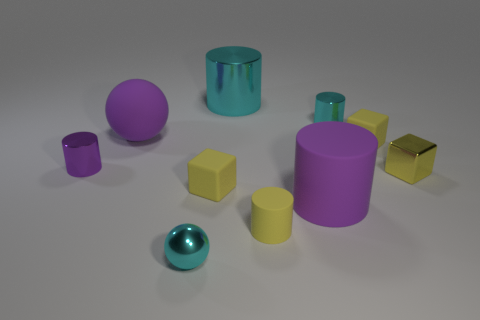Is there any other thing that is the same size as the matte sphere?
Keep it short and to the point. Yes. There is a small matte cube to the right of the small yellow rubber cylinder; is it the same color as the small matte cylinder?
Ensure brevity in your answer.  Yes. How many cubes are large cyan metallic things or tiny yellow objects?
Your response must be concise. 3. There is a cyan metallic thing in front of the yellow metal block; what shape is it?
Ensure brevity in your answer.  Sphere. There is a ball that is behind the cylinder left of the large thing that is to the left of the large cyan metal object; what color is it?
Provide a short and direct response. Purple. Is the cyan ball made of the same material as the large cyan thing?
Your answer should be very brief. Yes. What number of gray objects are big metal cylinders or metallic blocks?
Your answer should be compact. 0. There is a small purple cylinder; how many matte blocks are behind it?
Ensure brevity in your answer.  1. Is the number of small purple shiny cylinders greater than the number of large yellow metallic cylinders?
Your response must be concise. Yes. What is the shape of the tiny cyan thing in front of the cylinder in front of the big purple cylinder?
Your answer should be compact. Sphere. 